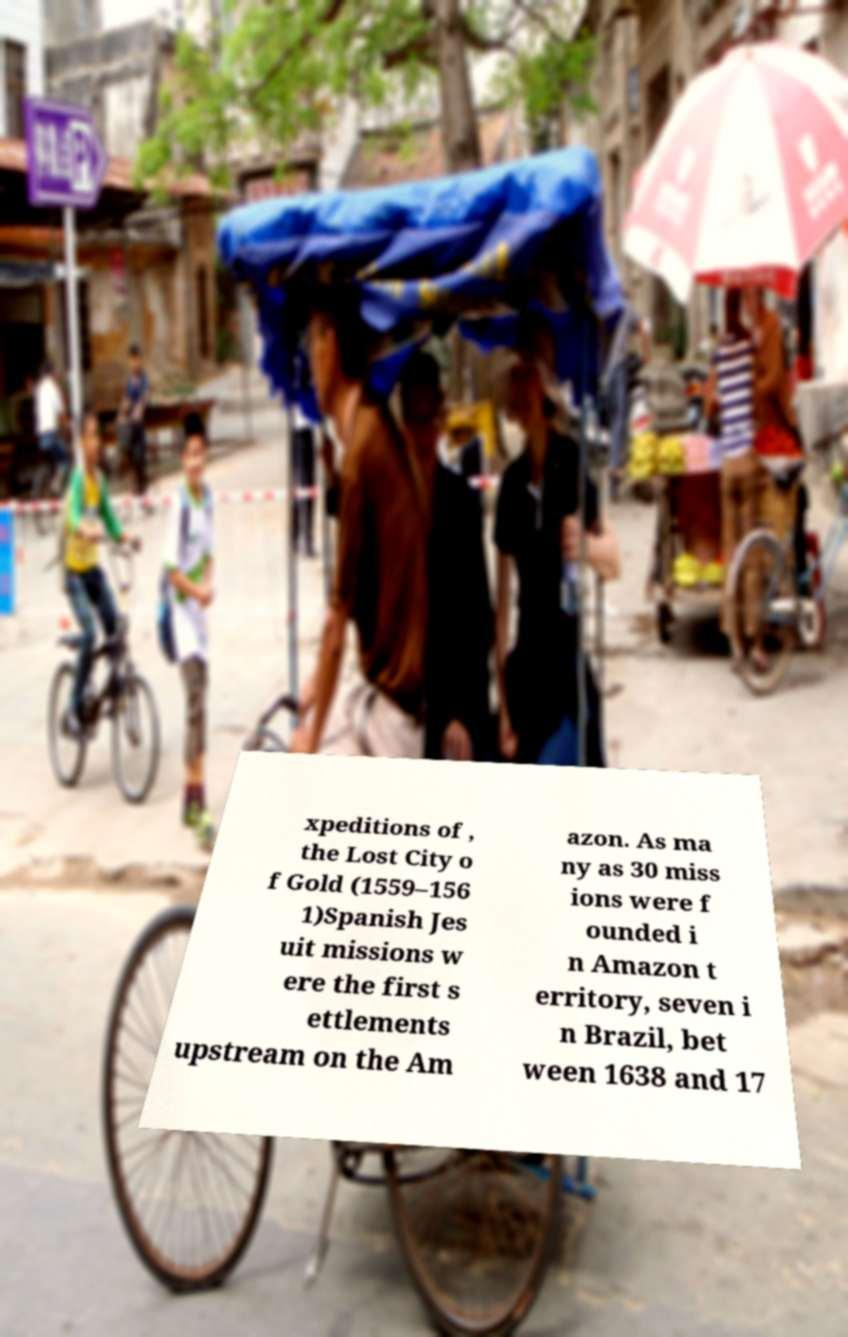Could you extract and type out the text from this image? xpeditions of , the Lost City o f Gold (1559–156 1)Spanish Jes uit missions w ere the first s ettlements upstream on the Am azon. As ma ny as 30 miss ions were f ounded i n Amazon t erritory, seven i n Brazil, bet ween 1638 and 17 